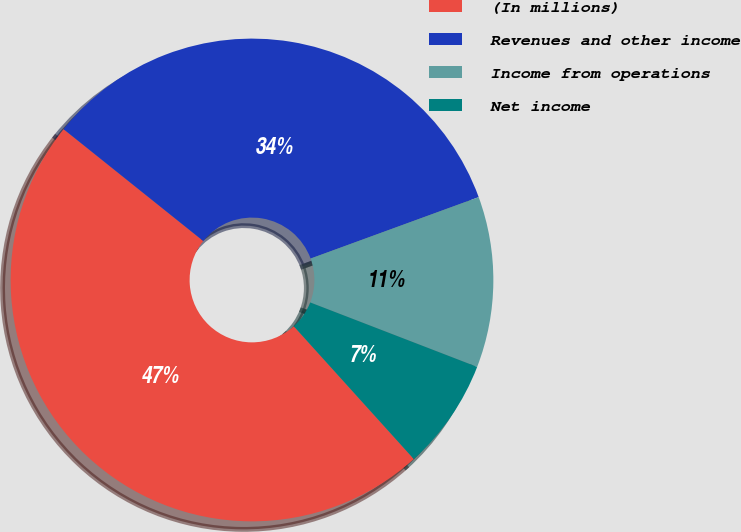<chart> <loc_0><loc_0><loc_500><loc_500><pie_chart><fcel>(In millions)<fcel>Revenues and other income<fcel>Income from operations<fcel>Net income<nl><fcel>47.44%<fcel>33.68%<fcel>11.44%<fcel>7.44%<nl></chart> 